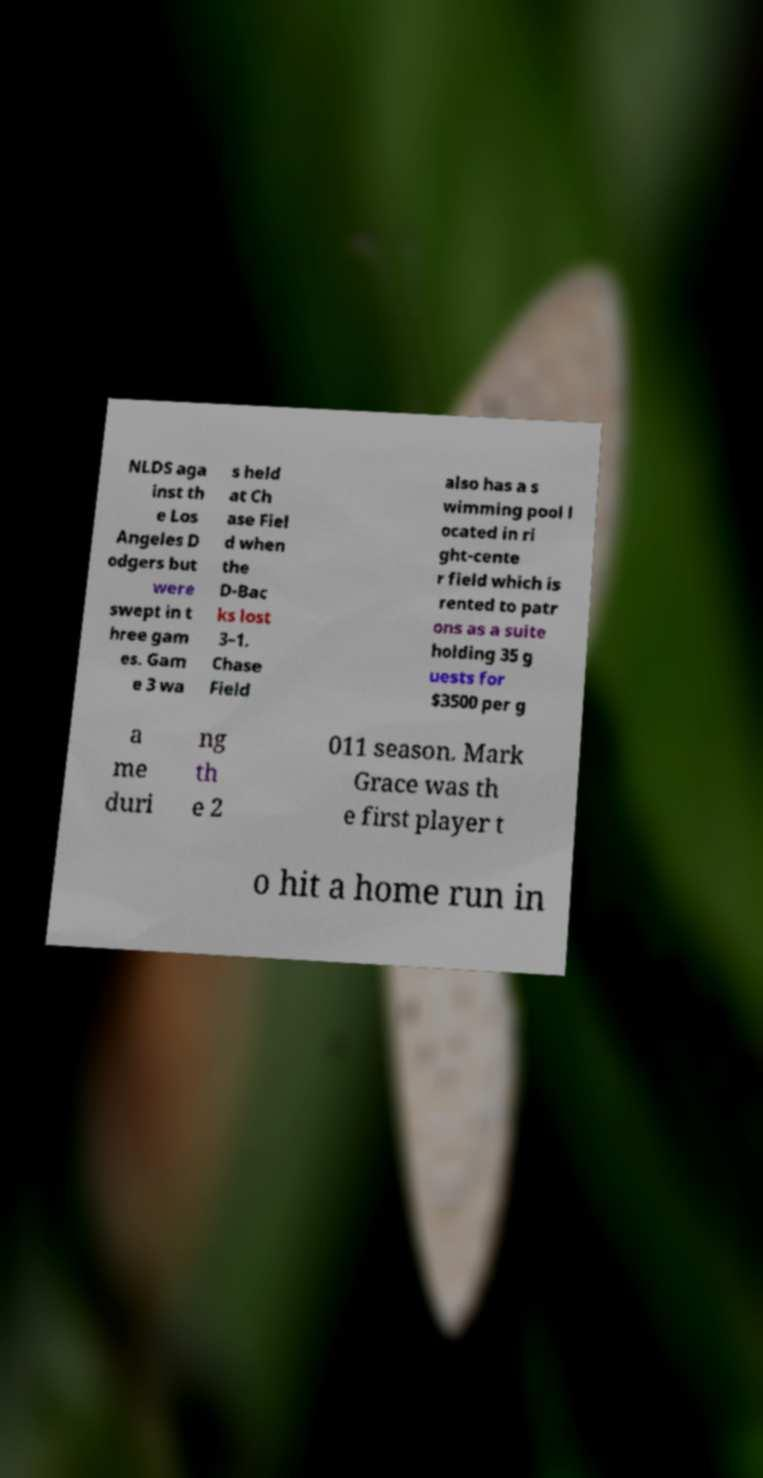There's text embedded in this image that I need extracted. Can you transcribe it verbatim? NLDS aga inst th e Los Angeles D odgers but were swept in t hree gam es. Gam e 3 wa s held at Ch ase Fiel d when the D-Bac ks lost 3–1. Chase Field also has a s wimming pool l ocated in ri ght-cente r field which is rented to patr ons as a suite holding 35 g uests for $3500 per g a me duri ng th e 2 011 season. Mark Grace was th e first player t o hit a home run in 